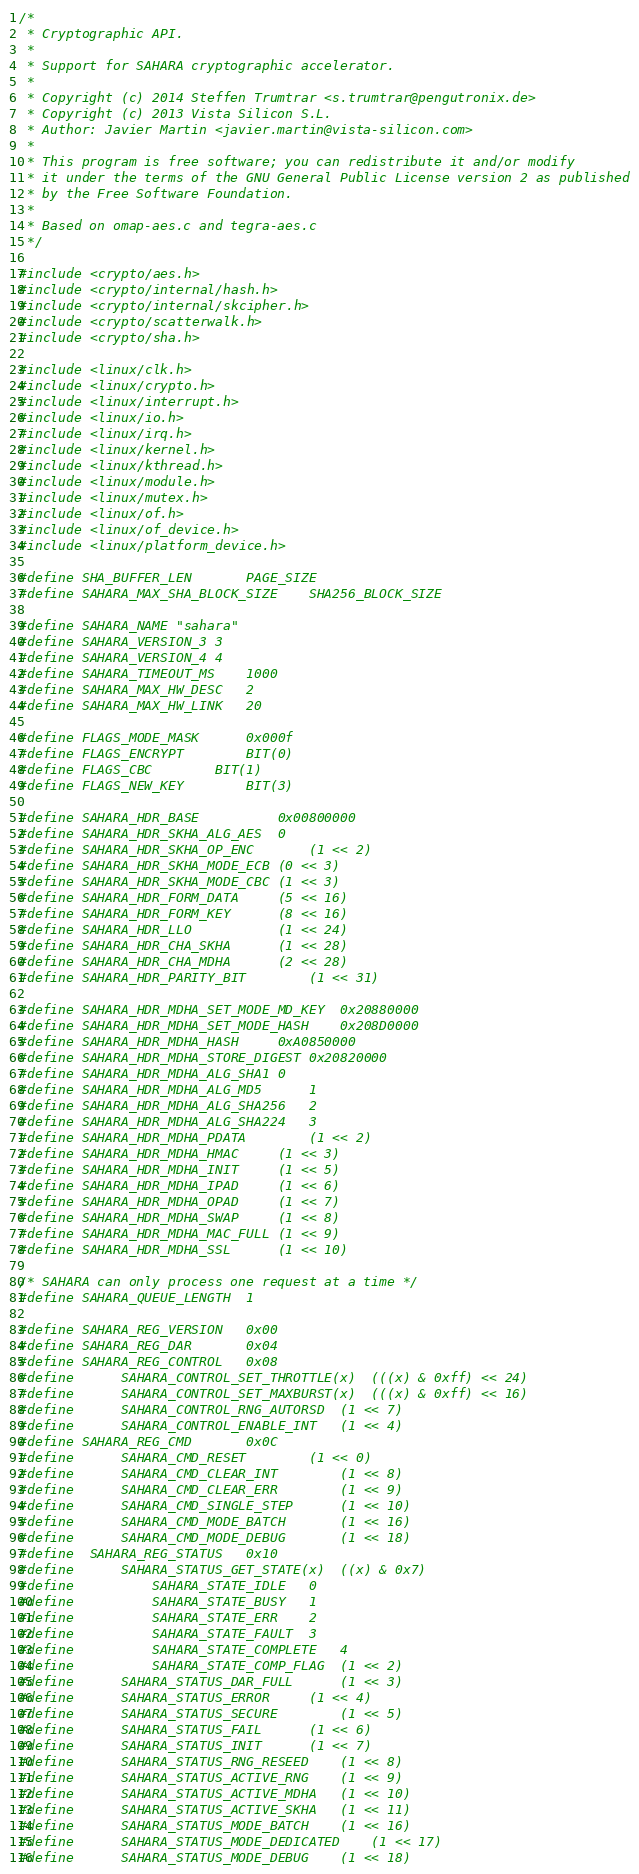<code> <loc_0><loc_0><loc_500><loc_500><_C_>/*
 * Cryptographic API.
 *
 * Support for SAHARA cryptographic accelerator.
 *
 * Copyright (c) 2014 Steffen Trumtrar <s.trumtrar@pengutronix.de>
 * Copyright (c) 2013 Vista Silicon S.L.
 * Author: Javier Martin <javier.martin@vista-silicon.com>
 *
 * This program is free software; you can redistribute it and/or modify
 * it under the terms of the GNU General Public License version 2 as published
 * by the Free Software Foundation.
 *
 * Based on omap-aes.c and tegra-aes.c
 */

#include <crypto/aes.h>
#include <crypto/internal/hash.h>
#include <crypto/internal/skcipher.h>
#include <crypto/scatterwalk.h>
#include <crypto/sha.h>

#include <linux/clk.h>
#include <linux/crypto.h>
#include <linux/interrupt.h>
#include <linux/io.h>
#include <linux/irq.h>
#include <linux/kernel.h>
#include <linux/kthread.h>
#include <linux/module.h>
#include <linux/mutex.h>
#include <linux/of.h>
#include <linux/of_device.h>
#include <linux/platform_device.h>

#define SHA_BUFFER_LEN		PAGE_SIZE
#define SAHARA_MAX_SHA_BLOCK_SIZE	SHA256_BLOCK_SIZE

#define SAHARA_NAME "sahara"
#define SAHARA_VERSION_3	3
#define SAHARA_VERSION_4	4
#define SAHARA_TIMEOUT_MS	1000
#define SAHARA_MAX_HW_DESC	2
#define SAHARA_MAX_HW_LINK	20

#define FLAGS_MODE_MASK		0x000f
#define FLAGS_ENCRYPT		BIT(0)
#define FLAGS_CBC		BIT(1)
#define FLAGS_NEW_KEY		BIT(3)

#define SAHARA_HDR_BASE			0x00800000
#define SAHARA_HDR_SKHA_ALG_AES	0
#define SAHARA_HDR_SKHA_OP_ENC		(1 << 2)
#define SAHARA_HDR_SKHA_MODE_ECB	(0 << 3)
#define SAHARA_HDR_SKHA_MODE_CBC	(1 << 3)
#define SAHARA_HDR_FORM_DATA		(5 << 16)
#define SAHARA_HDR_FORM_KEY		(8 << 16)
#define SAHARA_HDR_LLO			(1 << 24)
#define SAHARA_HDR_CHA_SKHA		(1 << 28)
#define SAHARA_HDR_CHA_MDHA		(2 << 28)
#define SAHARA_HDR_PARITY_BIT		(1 << 31)

#define SAHARA_HDR_MDHA_SET_MODE_MD_KEY	0x20880000
#define SAHARA_HDR_MDHA_SET_MODE_HASH	0x208D0000
#define SAHARA_HDR_MDHA_HASH		0xA0850000
#define SAHARA_HDR_MDHA_STORE_DIGEST	0x20820000
#define SAHARA_HDR_MDHA_ALG_SHA1	0
#define SAHARA_HDR_MDHA_ALG_MD5		1
#define SAHARA_HDR_MDHA_ALG_SHA256	2
#define SAHARA_HDR_MDHA_ALG_SHA224	3
#define SAHARA_HDR_MDHA_PDATA		(1 << 2)
#define SAHARA_HDR_MDHA_HMAC		(1 << 3)
#define SAHARA_HDR_MDHA_INIT		(1 << 5)
#define SAHARA_HDR_MDHA_IPAD		(1 << 6)
#define SAHARA_HDR_MDHA_OPAD		(1 << 7)
#define SAHARA_HDR_MDHA_SWAP		(1 << 8)
#define SAHARA_HDR_MDHA_MAC_FULL	(1 << 9)
#define SAHARA_HDR_MDHA_SSL		(1 << 10)

/* SAHARA can only process one request at a time */
#define SAHARA_QUEUE_LENGTH	1

#define SAHARA_REG_VERSION	0x00
#define SAHARA_REG_DAR		0x04
#define SAHARA_REG_CONTROL	0x08
#define		SAHARA_CONTROL_SET_THROTTLE(x)	(((x) & 0xff) << 24)
#define		SAHARA_CONTROL_SET_MAXBURST(x)	(((x) & 0xff) << 16)
#define		SAHARA_CONTROL_RNG_AUTORSD	(1 << 7)
#define		SAHARA_CONTROL_ENABLE_INT	(1 << 4)
#define SAHARA_REG_CMD		0x0C
#define		SAHARA_CMD_RESET		(1 << 0)
#define		SAHARA_CMD_CLEAR_INT		(1 << 8)
#define		SAHARA_CMD_CLEAR_ERR		(1 << 9)
#define		SAHARA_CMD_SINGLE_STEP		(1 << 10)
#define		SAHARA_CMD_MODE_BATCH		(1 << 16)
#define		SAHARA_CMD_MODE_DEBUG		(1 << 18)
#define	SAHARA_REG_STATUS	0x10
#define		SAHARA_STATUS_GET_STATE(x)	((x) & 0x7)
#define			SAHARA_STATE_IDLE	0
#define			SAHARA_STATE_BUSY	1
#define			SAHARA_STATE_ERR	2
#define			SAHARA_STATE_FAULT	3
#define			SAHARA_STATE_COMPLETE	4
#define			SAHARA_STATE_COMP_FLAG	(1 << 2)
#define		SAHARA_STATUS_DAR_FULL		(1 << 3)
#define		SAHARA_STATUS_ERROR		(1 << 4)
#define		SAHARA_STATUS_SECURE		(1 << 5)
#define		SAHARA_STATUS_FAIL		(1 << 6)
#define		SAHARA_STATUS_INIT		(1 << 7)
#define		SAHARA_STATUS_RNG_RESEED	(1 << 8)
#define		SAHARA_STATUS_ACTIVE_RNG	(1 << 9)
#define		SAHARA_STATUS_ACTIVE_MDHA	(1 << 10)
#define		SAHARA_STATUS_ACTIVE_SKHA	(1 << 11)
#define		SAHARA_STATUS_MODE_BATCH	(1 << 16)
#define		SAHARA_STATUS_MODE_DEDICATED	(1 << 17)
#define		SAHARA_STATUS_MODE_DEBUG	(1 << 18)</code> 